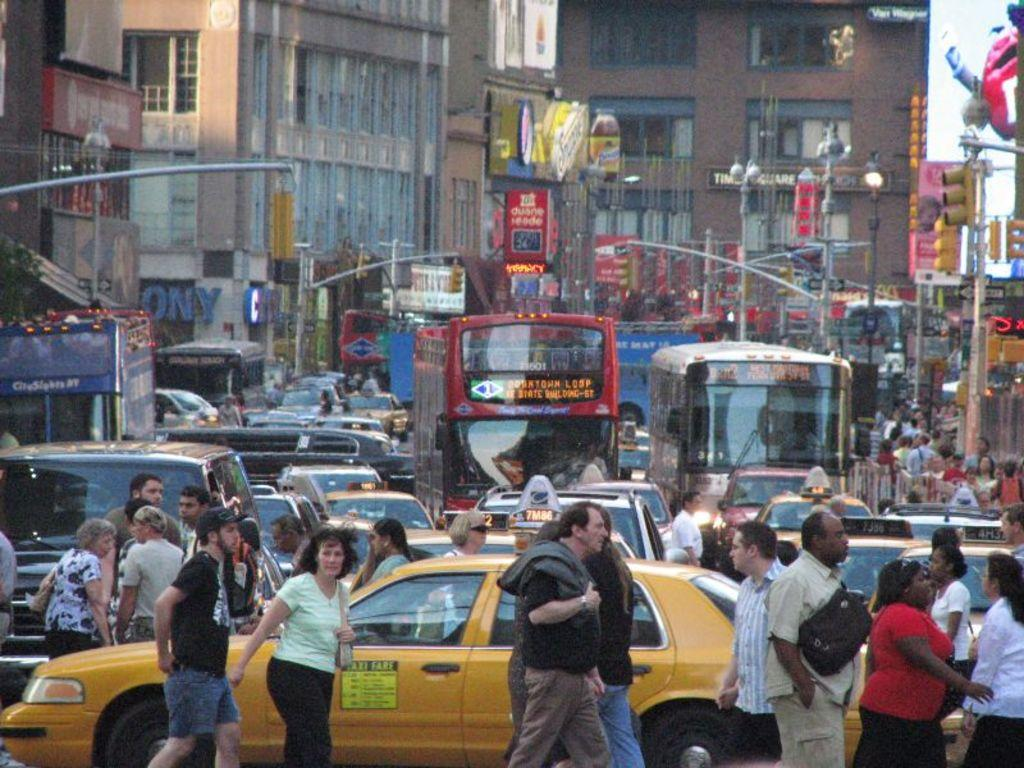<image>
Share a concise interpretation of the image provided. A busy street is filled with pedestrians, taxis, care, and buses along with stores like Sony in the distance. 